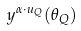Convert formula to latex. <formula><loc_0><loc_0><loc_500><loc_500>y ^ { \alpha \cdot u _ { Q } } ( \theta _ { Q } )</formula> 